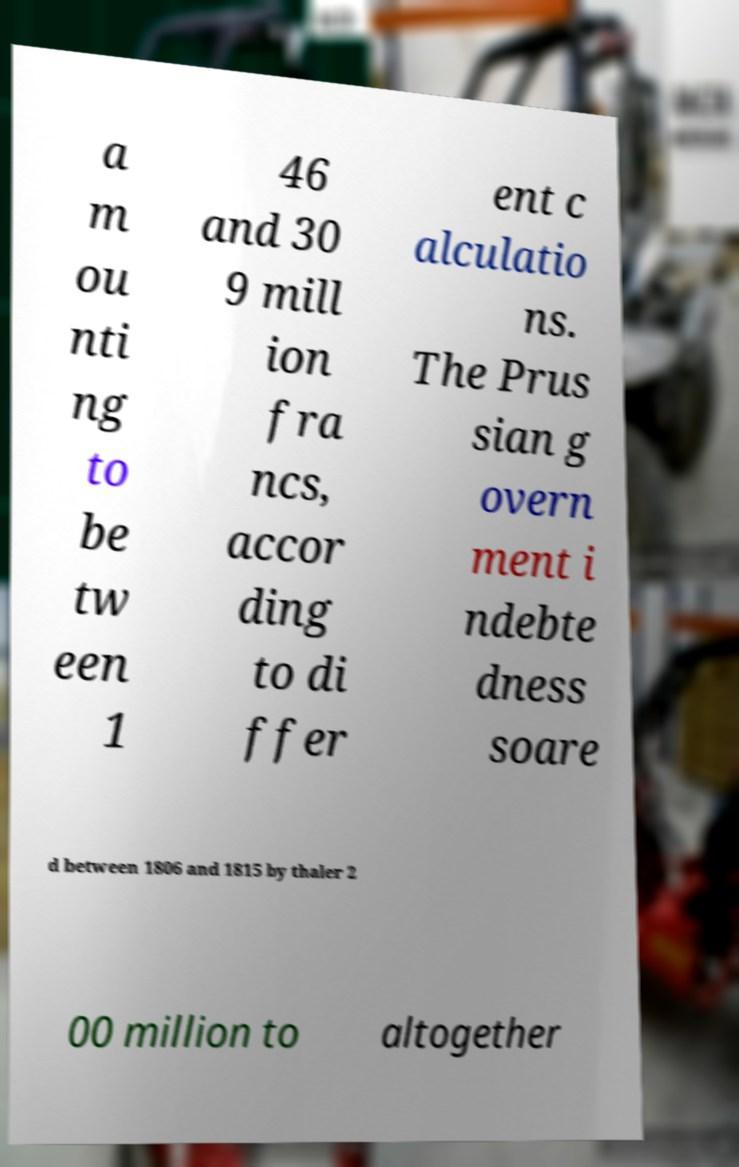Please identify and transcribe the text found in this image. a m ou nti ng to be tw een 1 46 and 30 9 mill ion fra ncs, accor ding to di ffer ent c alculatio ns. The Prus sian g overn ment i ndebte dness soare d between 1806 and 1815 by thaler 2 00 million to altogether 